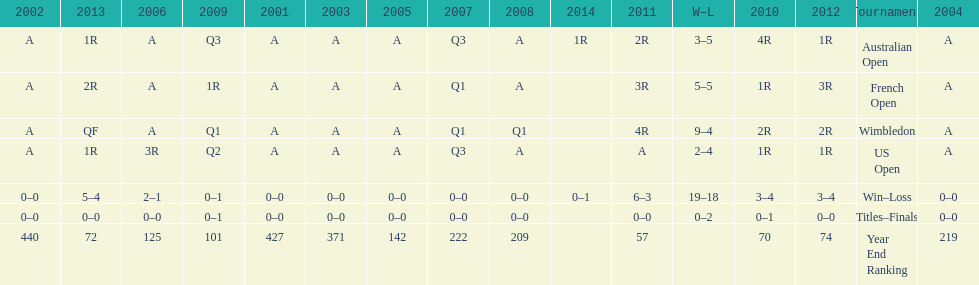How many tournaments had 5 total losses? 2. Parse the table in full. {'header': ['2002', '2013', '2006', '2009', '2001', '2003', '2005', '2007', '2008', '2014', '2011', 'W–L', '2010', '2012', 'Tournament', '2004'], 'rows': [['A', '1R', 'A', 'Q3', 'A', 'A', 'A', 'Q3', 'A', '1R', '2R', '3–5', '4R', '1R', 'Australian Open', 'A'], ['A', '2R', 'A', '1R', 'A', 'A', 'A', 'Q1', 'A', '', '3R', '5–5', '1R', '3R', 'French Open', 'A'], ['A', 'QF', 'A', 'Q1', 'A', 'A', 'A', 'Q1', 'Q1', '', '4R', '9–4', '2R', '2R', 'Wimbledon', 'A'], ['A', '1R', '3R', 'Q2', 'A', 'A', 'A', 'Q3', 'A', '', 'A', '2–4', '1R', '1R', 'US Open', 'A'], ['0–0', '5–4', '2–1', '0–1', '0–0', '0–0', '0–0', '0–0', '0–0', '0–1', '6–3', '19–18', '3–4', '3–4', 'Win–Loss', '0–0'], ['0–0', '0–0', '0–0', '0–1', '0–0', '0–0', '0–0', '0–0', '0–0', '', '0–0', '0–2', '0–1', '0–0', 'Titles–Finals', '0–0'], ['440', '72', '125', '101', '427', '371', '142', '222', '209', '', '57', '', '70', '74', 'Year End Ranking', '219']]} 